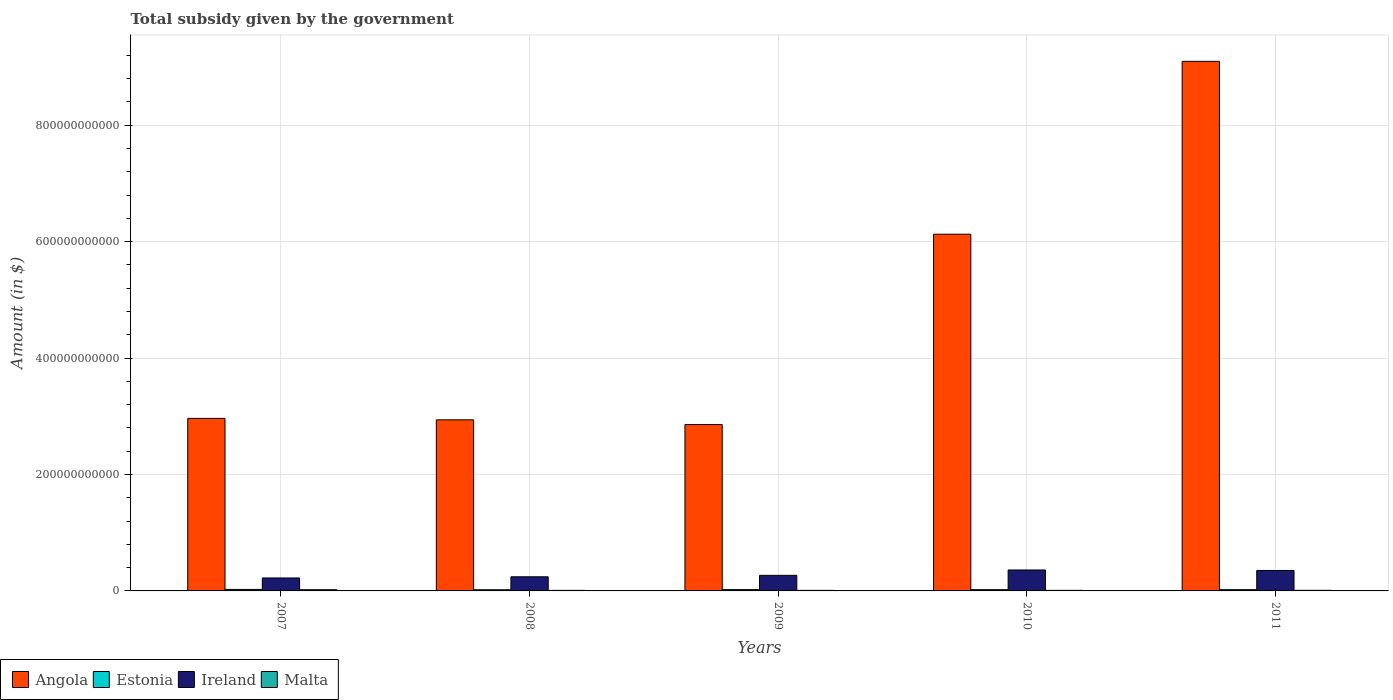How many different coloured bars are there?
Give a very brief answer. 4. How many groups of bars are there?
Offer a very short reply. 5. What is the total revenue collected by the government in Malta in 2011?
Provide a short and direct response. 1.02e+09. Across all years, what is the maximum total revenue collected by the government in Malta?
Your response must be concise. 2.07e+09. Across all years, what is the minimum total revenue collected by the government in Estonia?
Make the answer very short. 2.03e+09. In which year was the total revenue collected by the government in Angola maximum?
Your response must be concise. 2011. What is the total total revenue collected by the government in Estonia in the graph?
Provide a succinct answer. 1.12e+1. What is the difference between the total revenue collected by the government in Angola in 2008 and that in 2010?
Provide a short and direct response. -3.19e+11. What is the difference between the total revenue collected by the government in Ireland in 2007 and the total revenue collected by the government in Angola in 2009?
Keep it short and to the point. -2.64e+11. What is the average total revenue collected by the government in Malta per year?
Provide a succinct answer. 1.19e+09. In the year 2010, what is the difference between the total revenue collected by the government in Estonia and total revenue collected by the government in Ireland?
Ensure brevity in your answer.  -3.38e+1. What is the ratio of the total revenue collected by the government in Ireland in 2009 to that in 2011?
Your answer should be compact. 0.76. Is the total revenue collected by the government in Malta in 2008 less than that in 2010?
Offer a terse response. Yes. Is the difference between the total revenue collected by the government in Estonia in 2010 and 2011 greater than the difference between the total revenue collected by the government in Ireland in 2010 and 2011?
Provide a succinct answer. No. What is the difference between the highest and the second highest total revenue collected by the government in Malta?
Your answer should be compact. 1.04e+09. What is the difference between the highest and the lowest total revenue collected by the government in Ireland?
Offer a very short reply. 1.37e+1. Is it the case that in every year, the sum of the total revenue collected by the government in Angola and total revenue collected by the government in Malta is greater than the sum of total revenue collected by the government in Ireland and total revenue collected by the government in Estonia?
Your answer should be compact. Yes. What does the 4th bar from the left in 2008 represents?
Provide a short and direct response. Malta. What does the 3rd bar from the right in 2008 represents?
Provide a short and direct response. Estonia. Are all the bars in the graph horizontal?
Provide a short and direct response. No. How many years are there in the graph?
Keep it short and to the point. 5. What is the difference between two consecutive major ticks on the Y-axis?
Make the answer very short. 2.00e+11. Are the values on the major ticks of Y-axis written in scientific E-notation?
Keep it short and to the point. No. Does the graph contain any zero values?
Keep it short and to the point. No. Where does the legend appear in the graph?
Your answer should be very brief. Bottom left. How many legend labels are there?
Your response must be concise. 4. How are the legend labels stacked?
Keep it short and to the point. Horizontal. What is the title of the graph?
Your response must be concise. Total subsidy given by the government. Does "Belarus" appear as one of the legend labels in the graph?
Offer a very short reply. No. What is the label or title of the Y-axis?
Keep it short and to the point. Amount (in $). What is the Amount (in $) of Angola in 2007?
Your answer should be compact. 2.96e+11. What is the Amount (in $) of Estonia in 2007?
Make the answer very short. 2.59e+09. What is the Amount (in $) in Ireland in 2007?
Give a very brief answer. 2.23e+1. What is the Amount (in $) of Malta in 2007?
Offer a very short reply. 2.07e+09. What is the Amount (in $) in Angola in 2008?
Your answer should be compact. 2.94e+11. What is the Amount (in $) in Estonia in 2008?
Provide a succinct answer. 2.03e+09. What is the Amount (in $) in Ireland in 2008?
Give a very brief answer. 2.43e+1. What is the Amount (in $) in Malta in 2008?
Provide a short and direct response. 9.47e+08. What is the Amount (in $) in Angola in 2009?
Ensure brevity in your answer.  2.86e+11. What is the Amount (in $) in Estonia in 2009?
Make the answer very short. 2.23e+09. What is the Amount (in $) of Ireland in 2009?
Provide a succinct answer. 2.68e+1. What is the Amount (in $) of Malta in 2009?
Offer a very short reply. 9.47e+08. What is the Amount (in $) of Angola in 2010?
Provide a short and direct response. 6.13e+11. What is the Amount (in $) of Estonia in 2010?
Provide a succinct answer. 2.18e+09. What is the Amount (in $) of Ireland in 2010?
Your answer should be compact. 3.60e+1. What is the Amount (in $) in Malta in 2010?
Ensure brevity in your answer.  9.90e+08. What is the Amount (in $) of Angola in 2011?
Provide a short and direct response. 9.10e+11. What is the Amount (in $) in Estonia in 2011?
Your answer should be compact. 2.20e+09. What is the Amount (in $) of Ireland in 2011?
Provide a succinct answer. 3.51e+1. What is the Amount (in $) of Malta in 2011?
Offer a very short reply. 1.02e+09. Across all years, what is the maximum Amount (in $) in Angola?
Offer a very short reply. 9.10e+11. Across all years, what is the maximum Amount (in $) of Estonia?
Provide a short and direct response. 2.59e+09. Across all years, what is the maximum Amount (in $) in Ireland?
Offer a very short reply. 3.60e+1. Across all years, what is the maximum Amount (in $) of Malta?
Your answer should be very brief. 2.07e+09. Across all years, what is the minimum Amount (in $) of Angola?
Your answer should be very brief. 2.86e+11. Across all years, what is the minimum Amount (in $) of Estonia?
Offer a terse response. 2.03e+09. Across all years, what is the minimum Amount (in $) of Ireland?
Your answer should be very brief. 2.23e+1. Across all years, what is the minimum Amount (in $) in Malta?
Provide a succinct answer. 9.47e+08. What is the total Amount (in $) in Angola in the graph?
Provide a short and direct response. 2.40e+12. What is the total Amount (in $) of Estonia in the graph?
Offer a terse response. 1.12e+1. What is the total Amount (in $) in Ireland in the graph?
Offer a terse response. 1.44e+11. What is the total Amount (in $) of Malta in the graph?
Make the answer very short. 5.97e+09. What is the difference between the Amount (in $) of Angola in 2007 and that in 2008?
Your answer should be very brief. 2.50e+09. What is the difference between the Amount (in $) in Estonia in 2007 and that in 2008?
Your answer should be compact. 5.59e+08. What is the difference between the Amount (in $) of Ireland in 2007 and that in 2008?
Your answer should be compact. -2.01e+09. What is the difference between the Amount (in $) in Malta in 2007 and that in 2008?
Make the answer very short. 1.12e+09. What is the difference between the Amount (in $) in Angola in 2007 and that in 2009?
Your answer should be very brief. 1.06e+1. What is the difference between the Amount (in $) in Estonia in 2007 and that in 2009?
Your response must be concise. 3.53e+08. What is the difference between the Amount (in $) in Ireland in 2007 and that in 2009?
Provide a short and direct response. -4.49e+09. What is the difference between the Amount (in $) of Malta in 2007 and that in 2009?
Offer a very short reply. 1.12e+09. What is the difference between the Amount (in $) of Angola in 2007 and that in 2010?
Ensure brevity in your answer.  -3.16e+11. What is the difference between the Amount (in $) in Estonia in 2007 and that in 2010?
Offer a terse response. 4.08e+08. What is the difference between the Amount (in $) of Ireland in 2007 and that in 2010?
Your answer should be compact. -1.37e+1. What is the difference between the Amount (in $) of Malta in 2007 and that in 2010?
Make the answer very short. 1.08e+09. What is the difference between the Amount (in $) in Angola in 2007 and that in 2011?
Give a very brief answer. -6.13e+11. What is the difference between the Amount (in $) in Estonia in 2007 and that in 2011?
Provide a succinct answer. 3.87e+08. What is the difference between the Amount (in $) of Ireland in 2007 and that in 2011?
Your answer should be compact. -1.29e+1. What is the difference between the Amount (in $) of Malta in 2007 and that in 2011?
Provide a succinct answer. 1.04e+09. What is the difference between the Amount (in $) in Angola in 2008 and that in 2009?
Your response must be concise. 8.11e+09. What is the difference between the Amount (in $) in Estonia in 2008 and that in 2009?
Ensure brevity in your answer.  -2.07e+08. What is the difference between the Amount (in $) of Ireland in 2008 and that in 2009?
Your answer should be very brief. -2.48e+09. What is the difference between the Amount (in $) in Malta in 2008 and that in 2009?
Your response must be concise. -3.06e+05. What is the difference between the Amount (in $) of Angola in 2008 and that in 2010?
Make the answer very short. -3.19e+11. What is the difference between the Amount (in $) of Estonia in 2008 and that in 2010?
Provide a short and direct response. -1.51e+08. What is the difference between the Amount (in $) of Ireland in 2008 and that in 2010?
Ensure brevity in your answer.  -1.17e+1. What is the difference between the Amount (in $) of Malta in 2008 and that in 2010?
Provide a short and direct response. -4.33e+07. What is the difference between the Amount (in $) in Angola in 2008 and that in 2011?
Make the answer very short. -6.16e+11. What is the difference between the Amount (in $) in Estonia in 2008 and that in 2011?
Offer a terse response. -1.73e+08. What is the difference between the Amount (in $) in Ireland in 2008 and that in 2011?
Give a very brief answer. -1.09e+1. What is the difference between the Amount (in $) in Malta in 2008 and that in 2011?
Provide a succinct answer. -7.50e+07. What is the difference between the Amount (in $) of Angola in 2009 and that in 2010?
Make the answer very short. -3.27e+11. What is the difference between the Amount (in $) of Estonia in 2009 and that in 2010?
Make the answer very short. 5.54e+07. What is the difference between the Amount (in $) of Ireland in 2009 and that in 2010?
Make the answer very short. -9.21e+09. What is the difference between the Amount (in $) in Malta in 2009 and that in 2010?
Keep it short and to the point. -4.30e+07. What is the difference between the Amount (in $) in Angola in 2009 and that in 2011?
Keep it short and to the point. -6.24e+11. What is the difference between the Amount (in $) of Estonia in 2009 and that in 2011?
Offer a terse response. 3.40e+07. What is the difference between the Amount (in $) in Ireland in 2009 and that in 2011?
Ensure brevity in your answer.  -8.38e+09. What is the difference between the Amount (in $) of Malta in 2009 and that in 2011?
Make the answer very short. -7.47e+07. What is the difference between the Amount (in $) of Angola in 2010 and that in 2011?
Your answer should be very brief. -2.97e+11. What is the difference between the Amount (in $) of Estonia in 2010 and that in 2011?
Offer a terse response. -2.14e+07. What is the difference between the Amount (in $) of Ireland in 2010 and that in 2011?
Give a very brief answer. 8.34e+08. What is the difference between the Amount (in $) of Malta in 2010 and that in 2011?
Provide a short and direct response. -3.17e+07. What is the difference between the Amount (in $) of Angola in 2007 and the Amount (in $) of Estonia in 2008?
Offer a very short reply. 2.94e+11. What is the difference between the Amount (in $) in Angola in 2007 and the Amount (in $) in Ireland in 2008?
Give a very brief answer. 2.72e+11. What is the difference between the Amount (in $) of Angola in 2007 and the Amount (in $) of Malta in 2008?
Offer a very short reply. 2.95e+11. What is the difference between the Amount (in $) of Estonia in 2007 and the Amount (in $) of Ireland in 2008?
Your response must be concise. -2.17e+1. What is the difference between the Amount (in $) in Estonia in 2007 and the Amount (in $) in Malta in 2008?
Offer a very short reply. 1.64e+09. What is the difference between the Amount (in $) in Ireland in 2007 and the Amount (in $) in Malta in 2008?
Make the answer very short. 2.13e+1. What is the difference between the Amount (in $) of Angola in 2007 and the Amount (in $) of Estonia in 2009?
Keep it short and to the point. 2.94e+11. What is the difference between the Amount (in $) of Angola in 2007 and the Amount (in $) of Ireland in 2009?
Provide a succinct answer. 2.70e+11. What is the difference between the Amount (in $) of Angola in 2007 and the Amount (in $) of Malta in 2009?
Ensure brevity in your answer.  2.95e+11. What is the difference between the Amount (in $) of Estonia in 2007 and the Amount (in $) of Ireland in 2009?
Make the answer very short. -2.42e+1. What is the difference between the Amount (in $) of Estonia in 2007 and the Amount (in $) of Malta in 2009?
Keep it short and to the point. 1.64e+09. What is the difference between the Amount (in $) of Ireland in 2007 and the Amount (in $) of Malta in 2009?
Provide a succinct answer. 2.13e+1. What is the difference between the Amount (in $) in Angola in 2007 and the Amount (in $) in Estonia in 2010?
Your answer should be very brief. 2.94e+11. What is the difference between the Amount (in $) in Angola in 2007 and the Amount (in $) in Ireland in 2010?
Make the answer very short. 2.60e+11. What is the difference between the Amount (in $) in Angola in 2007 and the Amount (in $) in Malta in 2010?
Offer a very short reply. 2.95e+11. What is the difference between the Amount (in $) in Estonia in 2007 and the Amount (in $) in Ireland in 2010?
Ensure brevity in your answer.  -3.34e+1. What is the difference between the Amount (in $) in Estonia in 2007 and the Amount (in $) in Malta in 2010?
Your response must be concise. 1.60e+09. What is the difference between the Amount (in $) in Ireland in 2007 and the Amount (in $) in Malta in 2010?
Offer a very short reply. 2.13e+1. What is the difference between the Amount (in $) of Angola in 2007 and the Amount (in $) of Estonia in 2011?
Offer a very short reply. 2.94e+11. What is the difference between the Amount (in $) of Angola in 2007 and the Amount (in $) of Ireland in 2011?
Your answer should be very brief. 2.61e+11. What is the difference between the Amount (in $) in Angola in 2007 and the Amount (in $) in Malta in 2011?
Give a very brief answer. 2.95e+11. What is the difference between the Amount (in $) of Estonia in 2007 and the Amount (in $) of Ireland in 2011?
Offer a very short reply. -3.25e+1. What is the difference between the Amount (in $) of Estonia in 2007 and the Amount (in $) of Malta in 2011?
Your answer should be compact. 1.56e+09. What is the difference between the Amount (in $) of Ireland in 2007 and the Amount (in $) of Malta in 2011?
Your response must be concise. 2.12e+1. What is the difference between the Amount (in $) of Angola in 2008 and the Amount (in $) of Estonia in 2009?
Make the answer very short. 2.92e+11. What is the difference between the Amount (in $) in Angola in 2008 and the Amount (in $) in Ireland in 2009?
Make the answer very short. 2.67e+11. What is the difference between the Amount (in $) in Angola in 2008 and the Amount (in $) in Malta in 2009?
Give a very brief answer. 2.93e+11. What is the difference between the Amount (in $) of Estonia in 2008 and the Amount (in $) of Ireland in 2009?
Keep it short and to the point. -2.47e+1. What is the difference between the Amount (in $) in Estonia in 2008 and the Amount (in $) in Malta in 2009?
Make the answer very short. 1.08e+09. What is the difference between the Amount (in $) in Ireland in 2008 and the Amount (in $) in Malta in 2009?
Give a very brief answer. 2.33e+1. What is the difference between the Amount (in $) of Angola in 2008 and the Amount (in $) of Estonia in 2010?
Your answer should be very brief. 2.92e+11. What is the difference between the Amount (in $) of Angola in 2008 and the Amount (in $) of Ireland in 2010?
Your answer should be very brief. 2.58e+11. What is the difference between the Amount (in $) of Angola in 2008 and the Amount (in $) of Malta in 2010?
Offer a very short reply. 2.93e+11. What is the difference between the Amount (in $) of Estonia in 2008 and the Amount (in $) of Ireland in 2010?
Ensure brevity in your answer.  -3.39e+1. What is the difference between the Amount (in $) in Estonia in 2008 and the Amount (in $) in Malta in 2010?
Keep it short and to the point. 1.04e+09. What is the difference between the Amount (in $) in Ireland in 2008 and the Amount (in $) in Malta in 2010?
Offer a terse response. 2.33e+1. What is the difference between the Amount (in $) in Angola in 2008 and the Amount (in $) in Estonia in 2011?
Offer a terse response. 2.92e+11. What is the difference between the Amount (in $) in Angola in 2008 and the Amount (in $) in Ireland in 2011?
Give a very brief answer. 2.59e+11. What is the difference between the Amount (in $) of Angola in 2008 and the Amount (in $) of Malta in 2011?
Provide a succinct answer. 2.93e+11. What is the difference between the Amount (in $) in Estonia in 2008 and the Amount (in $) in Ireland in 2011?
Make the answer very short. -3.31e+1. What is the difference between the Amount (in $) of Estonia in 2008 and the Amount (in $) of Malta in 2011?
Your answer should be compact. 1.00e+09. What is the difference between the Amount (in $) of Ireland in 2008 and the Amount (in $) of Malta in 2011?
Give a very brief answer. 2.33e+1. What is the difference between the Amount (in $) in Angola in 2009 and the Amount (in $) in Estonia in 2010?
Provide a short and direct response. 2.84e+11. What is the difference between the Amount (in $) in Angola in 2009 and the Amount (in $) in Ireland in 2010?
Your response must be concise. 2.50e+11. What is the difference between the Amount (in $) in Angola in 2009 and the Amount (in $) in Malta in 2010?
Your response must be concise. 2.85e+11. What is the difference between the Amount (in $) of Estonia in 2009 and the Amount (in $) of Ireland in 2010?
Make the answer very short. -3.37e+1. What is the difference between the Amount (in $) of Estonia in 2009 and the Amount (in $) of Malta in 2010?
Ensure brevity in your answer.  1.24e+09. What is the difference between the Amount (in $) in Ireland in 2009 and the Amount (in $) in Malta in 2010?
Give a very brief answer. 2.58e+1. What is the difference between the Amount (in $) in Angola in 2009 and the Amount (in $) in Estonia in 2011?
Make the answer very short. 2.84e+11. What is the difference between the Amount (in $) in Angola in 2009 and the Amount (in $) in Ireland in 2011?
Make the answer very short. 2.51e+11. What is the difference between the Amount (in $) in Angola in 2009 and the Amount (in $) in Malta in 2011?
Keep it short and to the point. 2.85e+11. What is the difference between the Amount (in $) in Estonia in 2009 and the Amount (in $) in Ireland in 2011?
Offer a terse response. -3.29e+1. What is the difference between the Amount (in $) of Estonia in 2009 and the Amount (in $) of Malta in 2011?
Provide a succinct answer. 1.21e+09. What is the difference between the Amount (in $) of Ireland in 2009 and the Amount (in $) of Malta in 2011?
Keep it short and to the point. 2.57e+1. What is the difference between the Amount (in $) of Angola in 2010 and the Amount (in $) of Estonia in 2011?
Provide a succinct answer. 6.11e+11. What is the difference between the Amount (in $) in Angola in 2010 and the Amount (in $) in Ireland in 2011?
Your answer should be very brief. 5.78e+11. What is the difference between the Amount (in $) in Angola in 2010 and the Amount (in $) in Malta in 2011?
Your response must be concise. 6.12e+11. What is the difference between the Amount (in $) in Estonia in 2010 and the Amount (in $) in Ireland in 2011?
Make the answer very short. -3.30e+1. What is the difference between the Amount (in $) in Estonia in 2010 and the Amount (in $) in Malta in 2011?
Your response must be concise. 1.16e+09. What is the difference between the Amount (in $) of Ireland in 2010 and the Amount (in $) of Malta in 2011?
Make the answer very short. 3.49e+1. What is the average Amount (in $) of Angola per year?
Your response must be concise. 4.80e+11. What is the average Amount (in $) in Estonia per year?
Make the answer very short. 2.24e+09. What is the average Amount (in $) in Ireland per year?
Offer a very short reply. 2.89e+1. What is the average Amount (in $) of Malta per year?
Ensure brevity in your answer.  1.19e+09. In the year 2007, what is the difference between the Amount (in $) of Angola and Amount (in $) of Estonia?
Your response must be concise. 2.94e+11. In the year 2007, what is the difference between the Amount (in $) of Angola and Amount (in $) of Ireland?
Your answer should be compact. 2.74e+11. In the year 2007, what is the difference between the Amount (in $) in Angola and Amount (in $) in Malta?
Offer a terse response. 2.94e+11. In the year 2007, what is the difference between the Amount (in $) in Estonia and Amount (in $) in Ireland?
Provide a short and direct response. -1.97e+1. In the year 2007, what is the difference between the Amount (in $) in Estonia and Amount (in $) in Malta?
Make the answer very short. 5.19e+08. In the year 2007, what is the difference between the Amount (in $) in Ireland and Amount (in $) in Malta?
Provide a succinct answer. 2.02e+1. In the year 2008, what is the difference between the Amount (in $) in Angola and Amount (in $) in Estonia?
Your answer should be compact. 2.92e+11. In the year 2008, what is the difference between the Amount (in $) of Angola and Amount (in $) of Ireland?
Make the answer very short. 2.70e+11. In the year 2008, what is the difference between the Amount (in $) in Angola and Amount (in $) in Malta?
Make the answer very short. 2.93e+11. In the year 2008, what is the difference between the Amount (in $) of Estonia and Amount (in $) of Ireland?
Your response must be concise. -2.22e+1. In the year 2008, what is the difference between the Amount (in $) of Estonia and Amount (in $) of Malta?
Keep it short and to the point. 1.08e+09. In the year 2008, what is the difference between the Amount (in $) of Ireland and Amount (in $) of Malta?
Your answer should be very brief. 2.33e+1. In the year 2009, what is the difference between the Amount (in $) of Angola and Amount (in $) of Estonia?
Keep it short and to the point. 2.84e+11. In the year 2009, what is the difference between the Amount (in $) of Angola and Amount (in $) of Ireland?
Keep it short and to the point. 2.59e+11. In the year 2009, what is the difference between the Amount (in $) of Angola and Amount (in $) of Malta?
Your answer should be compact. 2.85e+11. In the year 2009, what is the difference between the Amount (in $) of Estonia and Amount (in $) of Ireland?
Provide a succinct answer. -2.45e+1. In the year 2009, what is the difference between the Amount (in $) of Estonia and Amount (in $) of Malta?
Make the answer very short. 1.29e+09. In the year 2009, what is the difference between the Amount (in $) in Ireland and Amount (in $) in Malta?
Give a very brief answer. 2.58e+1. In the year 2010, what is the difference between the Amount (in $) of Angola and Amount (in $) of Estonia?
Your answer should be very brief. 6.11e+11. In the year 2010, what is the difference between the Amount (in $) of Angola and Amount (in $) of Ireland?
Your response must be concise. 5.77e+11. In the year 2010, what is the difference between the Amount (in $) in Angola and Amount (in $) in Malta?
Give a very brief answer. 6.12e+11. In the year 2010, what is the difference between the Amount (in $) of Estonia and Amount (in $) of Ireland?
Provide a succinct answer. -3.38e+1. In the year 2010, what is the difference between the Amount (in $) of Estonia and Amount (in $) of Malta?
Provide a short and direct response. 1.19e+09. In the year 2010, what is the difference between the Amount (in $) in Ireland and Amount (in $) in Malta?
Give a very brief answer. 3.50e+1. In the year 2011, what is the difference between the Amount (in $) in Angola and Amount (in $) in Estonia?
Your answer should be compact. 9.07e+11. In the year 2011, what is the difference between the Amount (in $) in Angola and Amount (in $) in Ireland?
Ensure brevity in your answer.  8.74e+11. In the year 2011, what is the difference between the Amount (in $) of Angola and Amount (in $) of Malta?
Your response must be concise. 9.09e+11. In the year 2011, what is the difference between the Amount (in $) of Estonia and Amount (in $) of Ireland?
Your answer should be compact. -3.29e+1. In the year 2011, what is the difference between the Amount (in $) of Estonia and Amount (in $) of Malta?
Your response must be concise. 1.18e+09. In the year 2011, what is the difference between the Amount (in $) in Ireland and Amount (in $) in Malta?
Ensure brevity in your answer.  3.41e+1. What is the ratio of the Amount (in $) of Angola in 2007 to that in 2008?
Provide a short and direct response. 1.01. What is the ratio of the Amount (in $) in Estonia in 2007 to that in 2008?
Provide a succinct answer. 1.28. What is the ratio of the Amount (in $) of Ireland in 2007 to that in 2008?
Your response must be concise. 0.92. What is the ratio of the Amount (in $) in Malta in 2007 to that in 2008?
Ensure brevity in your answer.  2.18. What is the ratio of the Amount (in $) of Angola in 2007 to that in 2009?
Offer a terse response. 1.04. What is the ratio of the Amount (in $) of Estonia in 2007 to that in 2009?
Ensure brevity in your answer.  1.16. What is the ratio of the Amount (in $) in Ireland in 2007 to that in 2009?
Keep it short and to the point. 0.83. What is the ratio of the Amount (in $) in Malta in 2007 to that in 2009?
Your answer should be very brief. 2.18. What is the ratio of the Amount (in $) of Angola in 2007 to that in 2010?
Your answer should be compact. 0.48. What is the ratio of the Amount (in $) in Estonia in 2007 to that in 2010?
Offer a terse response. 1.19. What is the ratio of the Amount (in $) of Ireland in 2007 to that in 2010?
Offer a terse response. 0.62. What is the ratio of the Amount (in $) in Malta in 2007 to that in 2010?
Give a very brief answer. 2.09. What is the ratio of the Amount (in $) in Angola in 2007 to that in 2011?
Provide a short and direct response. 0.33. What is the ratio of the Amount (in $) in Estonia in 2007 to that in 2011?
Your answer should be compact. 1.18. What is the ratio of the Amount (in $) of Ireland in 2007 to that in 2011?
Ensure brevity in your answer.  0.63. What is the ratio of the Amount (in $) of Malta in 2007 to that in 2011?
Provide a succinct answer. 2.02. What is the ratio of the Amount (in $) of Angola in 2008 to that in 2009?
Your answer should be compact. 1.03. What is the ratio of the Amount (in $) of Estonia in 2008 to that in 2009?
Give a very brief answer. 0.91. What is the ratio of the Amount (in $) in Ireland in 2008 to that in 2009?
Make the answer very short. 0.91. What is the ratio of the Amount (in $) in Angola in 2008 to that in 2010?
Your answer should be compact. 0.48. What is the ratio of the Amount (in $) of Estonia in 2008 to that in 2010?
Ensure brevity in your answer.  0.93. What is the ratio of the Amount (in $) in Ireland in 2008 to that in 2010?
Provide a short and direct response. 0.68. What is the ratio of the Amount (in $) of Malta in 2008 to that in 2010?
Give a very brief answer. 0.96. What is the ratio of the Amount (in $) in Angola in 2008 to that in 2011?
Give a very brief answer. 0.32. What is the ratio of the Amount (in $) in Estonia in 2008 to that in 2011?
Your answer should be compact. 0.92. What is the ratio of the Amount (in $) of Ireland in 2008 to that in 2011?
Provide a short and direct response. 0.69. What is the ratio of the Amount (in $) of Malta in 2008 to that in 2011?
Your answer should be compact. 0.93. What is the ratio of the Amount (in $) in Angola in 2009 to that in 2010?
Your answer should be very brief. 0.47. What is the ratio of the Amount (in $) in Estonia in 2009 to that in 2010?
Give a very brief answer. 1.03. What is the ratio of the Amount (in $) in Ireland in 2009 to that in 2010?
Provide a short and direct response. 0.74. What is the ratio of the Amount (in $) in Malta in 2009 to that in 2010?
Provide a succinct answer. 0.96. What is the ratio of the Amount (in $) in Angola in 2009 to that in 2011?
Provide a succinct answer. 0.31. What is the ratio of the Amount (in $) of Estonia in 2009 to that in 2011?
Give a very brief answer. 1.02. What is the ratio of the Amount (in $) of Ireland in 2009 to that in 2011?
Offer a terse response. 0.76. What is the ratio of the Amount (in $) of Malta in 2009 to that in 2011?
Your answer should be compact. 0.93. What is the ratio of the Amount (in $) of Angola in 2010 to that in 2011?
Your answer should be very brief. 0.67. What is the ratio of the Amount (in $) in Estonia in 2010 to that in 2011?
Keep it short and to the point. 0.99. What is the ratio of the Amount (in $) in Ireland in 2010 to that in 2011?
Give a very brief answer. 1.02. What is the ratio of the Amount (in $) in Malta in 2010 to that in 2011?
Keep it short and to the point. 0.97. What is the difference between the highest and the second highest Amount (in $) of Angola?
Give a very brief answer. 2.97e+11. What is the difference between the highest and the second highest Amount (in $) in Estonia?
Ensure brevity in your answer.  3.53e+08. What is the difference between the highest and the second highest Amount (in $) of Ireland?
Offer a very short reply. 8.34e+08. What is the difference between the highest and the second highest Amount (in $) of Malta?
Make the answer very short. 1.04e+09. What is the difference between the highest and the lowest Amount (in $) of Angola?
Make the answer very short. 6.24e+11. What is the difference between the highest and the lowest Amount (in $) in Estonia?
Ensure brevity in your answer.  5.59e+08. What is the difference between the highest and the lowest Amount (in $) of Ireland?
Give a very brief answer. 1.37e+1. What is the difference between the highest and the lowest Amount (in $) of Malta?
Your answer should be compact. 1.12e+09. 